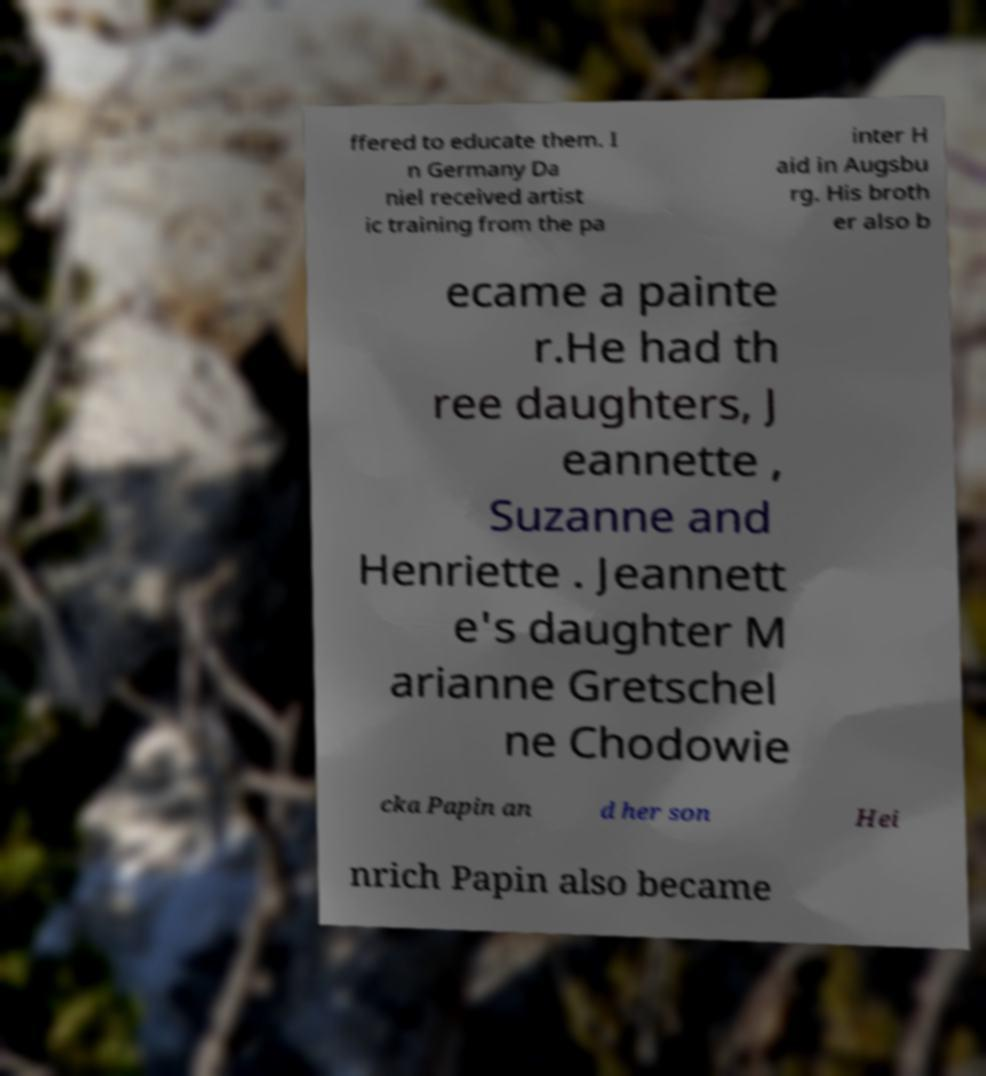Please identify and transcribe the text found in this image. ffered to educate them. I n Germany Da niel received artist ic training from the pa inter H aid in Augsbu rg. His broth er also b ecame a painte r.He had th ree daughters, J eannette , Suzanne and Henriette . Jeannett e's daughter M arianne Gretschel ne Chodowie cka Papin an d her son Hei nrich Papin also became 